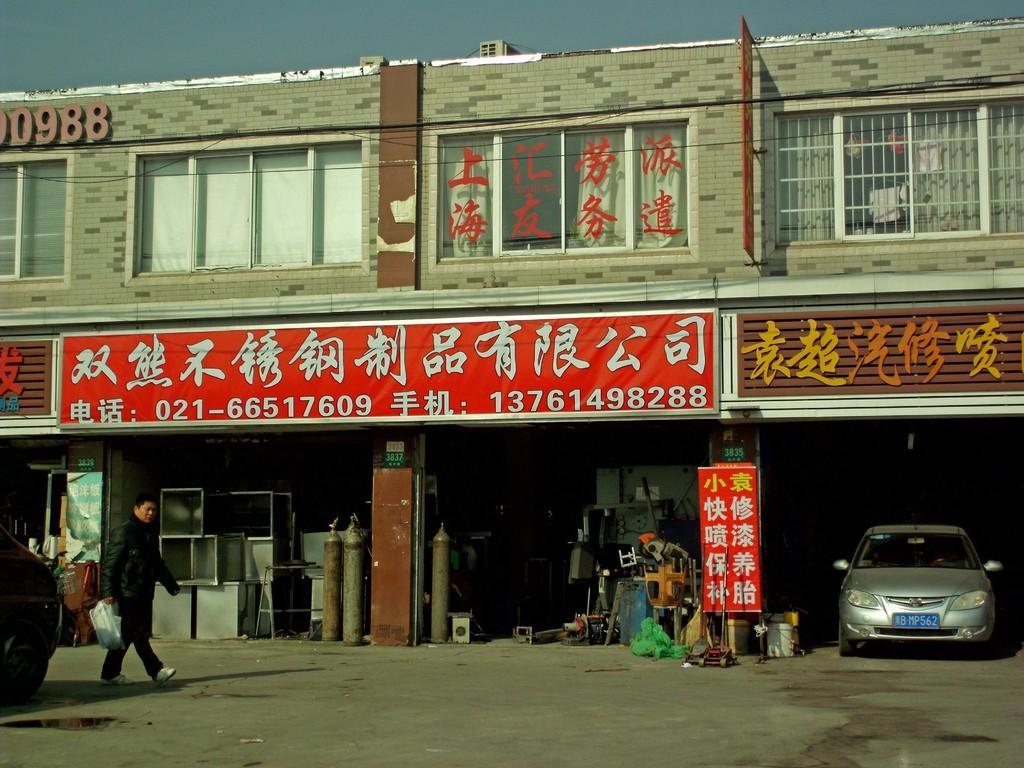How would you summarize this image in a sentence or two? In this image there is a person walking in front of a building on the road, beside the person there is some object, there is a car parked in the building, beside the car there is a shop with some objects, on top of the shops there is name board, on the building there are name boards and glass windows. 